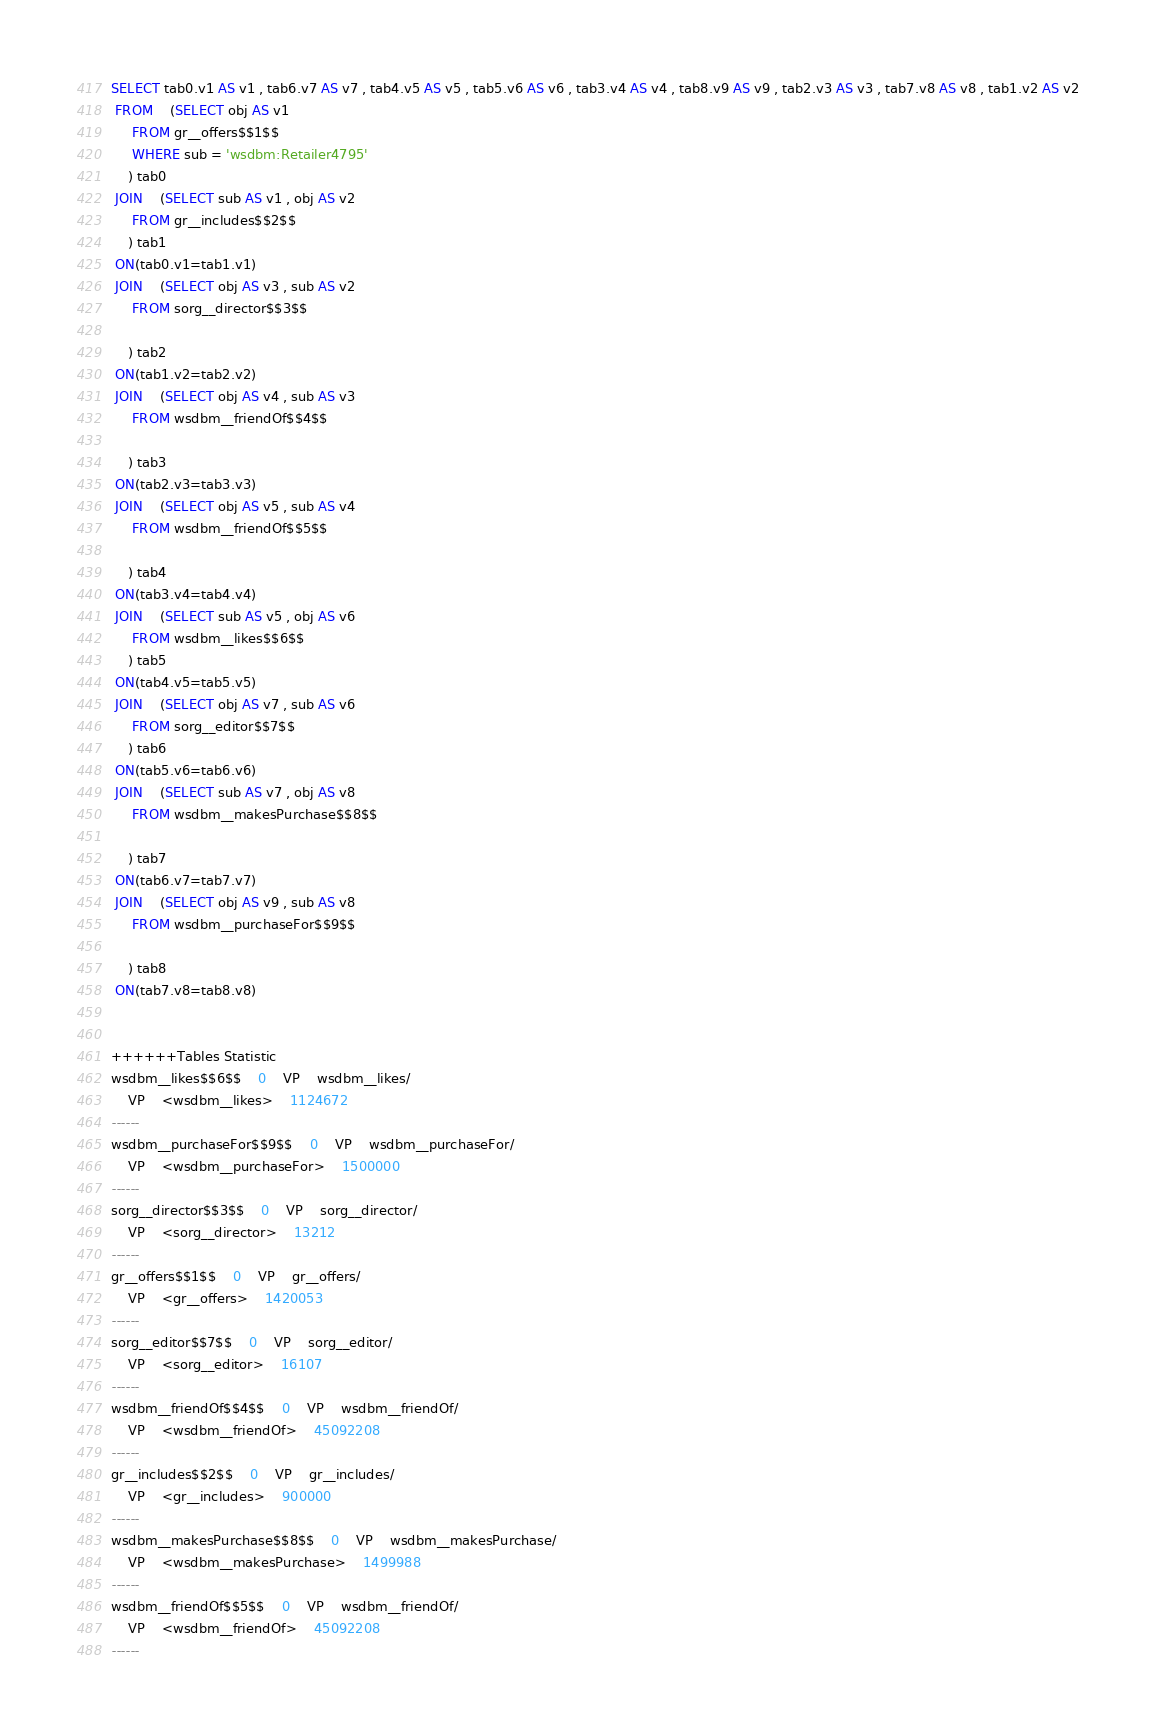Convert code to text. <code><loc_0><loc_0><loc_500><loc_500><_SQL_>SELECT tab0.v1 AS v1 , tab6.v7 AS v7 , tab4.v5 AS v5 , tab5.v6 AS v6 , tab3.v4 AS v4 , tab8.v9 AS v9 , tab2.v3 AS v3 , tab7.v8 AS v8 , tab1.v2 AS v2 
 FROM    (SELECT obj AS v1 
	 FROM gr__offers$$1$$ 
	 WHERE sub = 'wsdbm:Retailer4795'
	) tab0
 JOIN    (SELECT sub AS v1 , obj AS v2 
	 FROM gr__includes$$2$$
	) tab1
 ON(tab0.v1=tab1.v1)
 JOIN    (SELECT obj AS v3 , sub AS v2 
	 FROM sorg__director$$3$$
	
	) tab2
 ON(tab1.v2=tab2.v2)
 JOIN    (SELECT obj AS v4 , sub AS v3 
	 FROM wsdbm__friendOf$$4$$
	
	) tab3
 ON(tab2.v3=tab3.v3)
 JOIN    (SELECT obj AS v5 , sub AS v4 
	 FROM wsdbm__friendOf$$5$$
	
	) tab4
 ON(tab3.v4=tab4.v4)
 JOIN    (SELECT sub AS v5 , obj AS v6 
	 FROM wsdbm__likes$$6$$
	) tab5
 ON(tab4.v5=tab5.v5)
 JOIN    (SELECT obj AS v7 , sub AS v6 
	 FROM sorg__editor$$7$$
	) tab6
 ON(tab5.v6=tab6.v6)
 JOIN    (SELECT sub AS v7 , obj AS v8 
	 FROM wsdbm__makesPurchase$$8$$
	
	) tab7
 ON(tab6.v7=tab7.v7)
 JOIN    (SELECT obj AS v9 , sub AS v8 
	 FROM wsdbm__purchaseFor$$9$$
	
	) tab8
 ON(tab7.v8=tab8.v8)


++++++Tables Statistic
wsdbm__likes$$6$$	0	VP	wsdbm__likes/
	VP	<wsdbm__likes>	1124672
------
wsdbm__purchaseFor$$9$$	0	VP	wsdbm__purchaseFor/
	VP	<wsdbm__purchaseFor>	1500000
------
sorg__director$$3$$	0	VP	sorg__director/
	VP	<sorg__director>	13212
------
gr__offers$$1$$	0	VP	gr__offers/
	VP	<gr__offers>	1420053
------
sorg__editor$$7$$	0	VP	sorg__editor/
	VP	<sorg__editor>	16107
------
wsdbm__friendOf$$4$$	0	VP	wsdbm__friendOf/
	VP	<wsdbm__friendOf>	45092208
------
gr__includes$$2$$	0	VP	gr__includes/
	VP	<gr__includes>	900000
------
wsdbm__makesPurchase$$8$$	0	VP	wsdbm__makesPurchase/
	VP	<wsdbm__makesPurchase>	1499988
------
wsdbm__friendOf$$5$$	0	VP	wsdbm__friendOf/
	VP	<wsdbm__friendOf>	45092208
------
</code> 